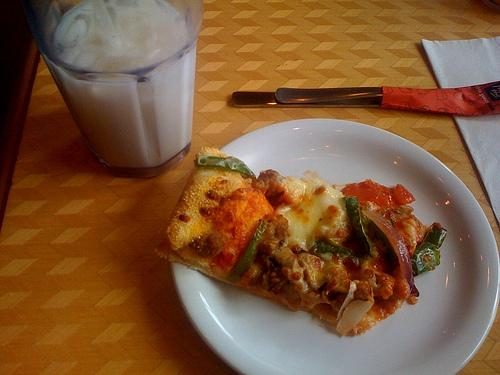How has this food been prepared for serving? Please explain your reasoning. sliced. Pizza is baked and sliced. 